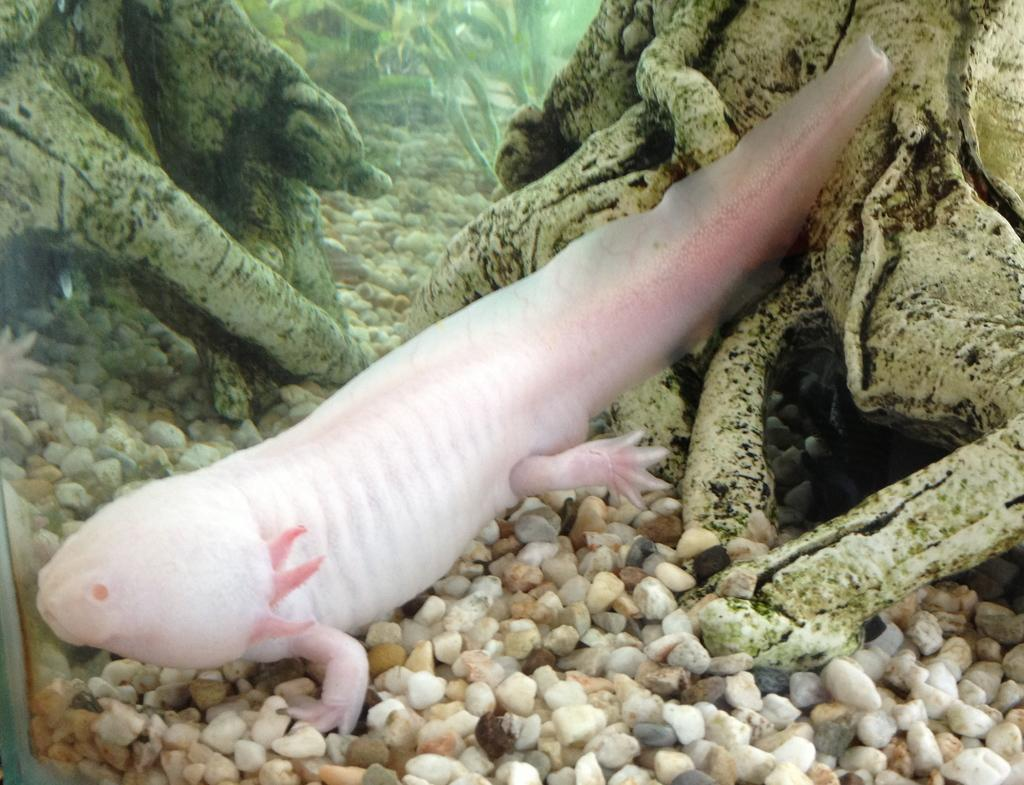What type of animal is in the image? There is a fish in the image. Where is the fish located? The fish is underwater. What can be seen in the background of the image? There are stones and trees visible in the background of the image. What is present at the bottom of the image? Stones are present at the bottom of the image. What flavor of art can be seen in the image? There is no art present in the image, and therefore no flavor can be associated with it. 